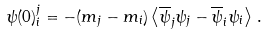<formula> <loc_0><loc_0><loc_500><loc_500>\psi ( 0 ) _ { i } ^ { j } = - ( m _ { j } - m _ { i } ) \left \langle \overline { \psi } _ { j } \psi _ { j } - \overline { \psi } _ { i } \psi _ { i } \right \rangle \, .</formula> 